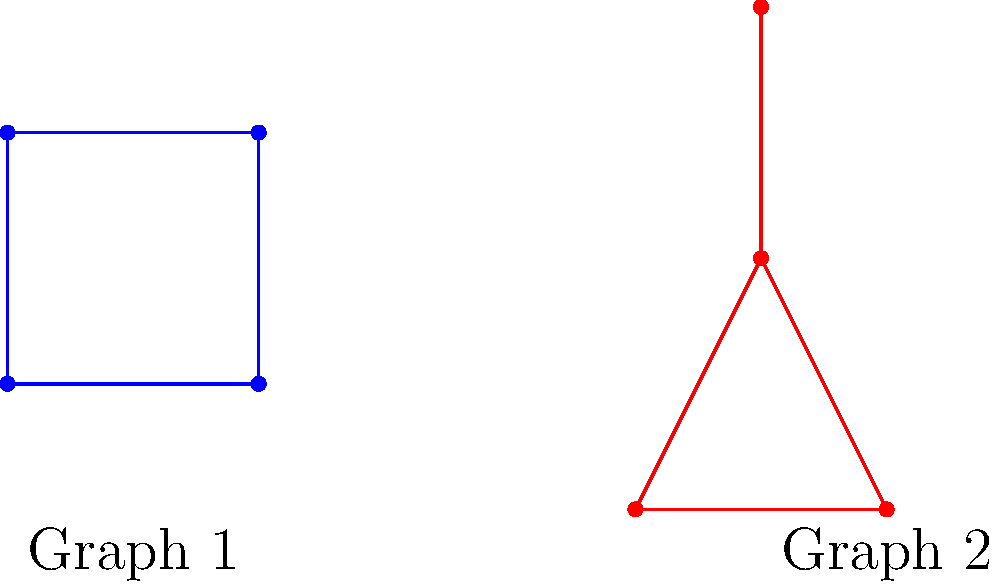As an education advocate promoting math literacy, you want to introduce topology concepts to advanced students. Consider the two graphs shown above. Are these graphs topologically equivalent? Justify your answer using the concept of homeomorphism. To determine if two graphs are topologically equivalent, we need to check if there exists a homeomorphism between them. A homeomorphism is a continuous function with a continuous inverse that maps one graph onto the other while preserving the connectivity of vertices.

Let's analyze the graphs step by step:

1. Vertex count: Both graphs have 4 vertices, which is a necessary (but not sufficient) condition for topological equivalence.

2. Edge count: Both graphs have 4 edges, which is also necessary but not sufficient.

3. Connectivity:
   - In Graph 1, we have:
     * One vertex of degree 1 (top-right)
     * Two vertices of degree 2 (top-left and bottom-right)
     * One vertex of degree 3 (bottom-left)
   - In Graph 2, we have:
     * One vertex of degree 1 (top)
     * Two vertices of degree 2 (bottom-left and bottom-right)
     * One vertex of degree 3 (center)

4. Homeomorphism: We can establish a homeomorphism between the graphs:
   - Map the degree-1 vertices to each other
   - Map the degree-3 vertices to each other
   - Map the two degree-2 vertices to each other in either way

5. Continuous deformation: We can imagine continuously deforming Graph 1 into Graph 2 without breaking or creating new connections:
   - Pull the top-right vertex upwards
   - Push the bottom-left vertex towards the center
   - Adjust the positions of the other two vertices accordingly

Since we can establish a homeomorphism between the graphs and visualize a continuous deformation from one to the other, we can conclude that these graphs are indeed topologically equivalent.
Answer: Yes, the graphs are topologically equivalent. 